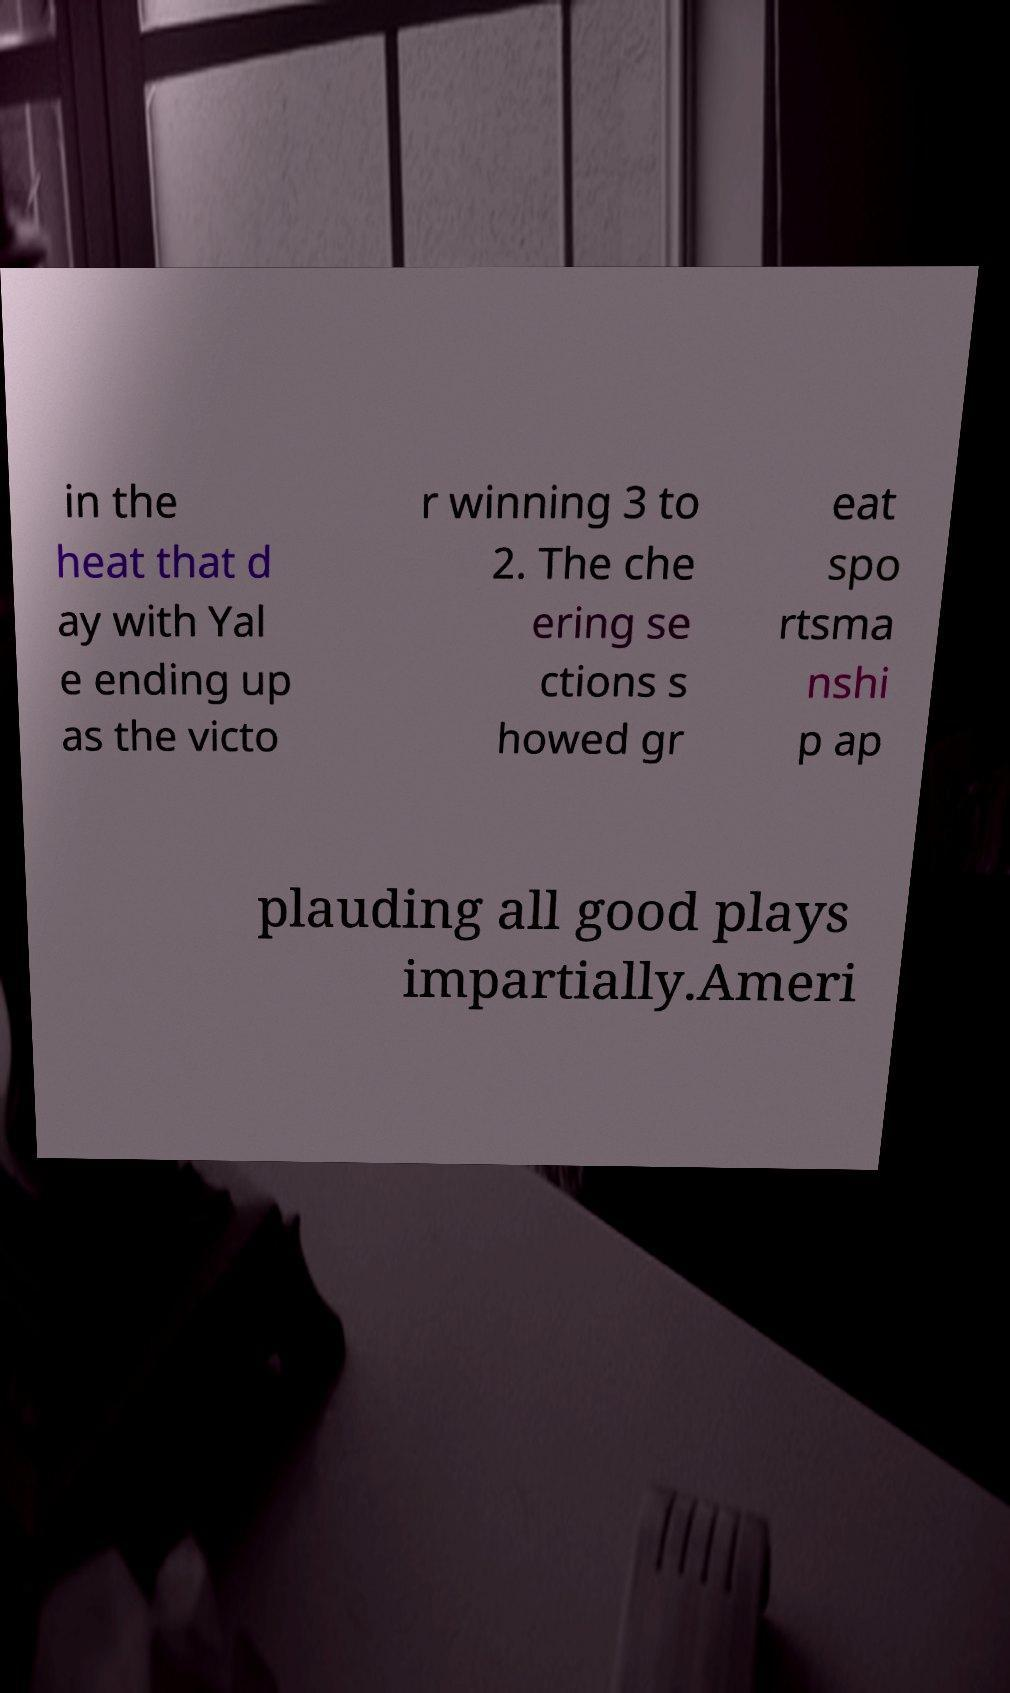I need the written content from this picture converted into text. Can you do that? in the heat that d ay with Yal e ending up as the victo r winning 3 to 2. The che ering se ctions s howed gr eat spo rtsma nshi p ap plauding all good plays impartially.Ameri 